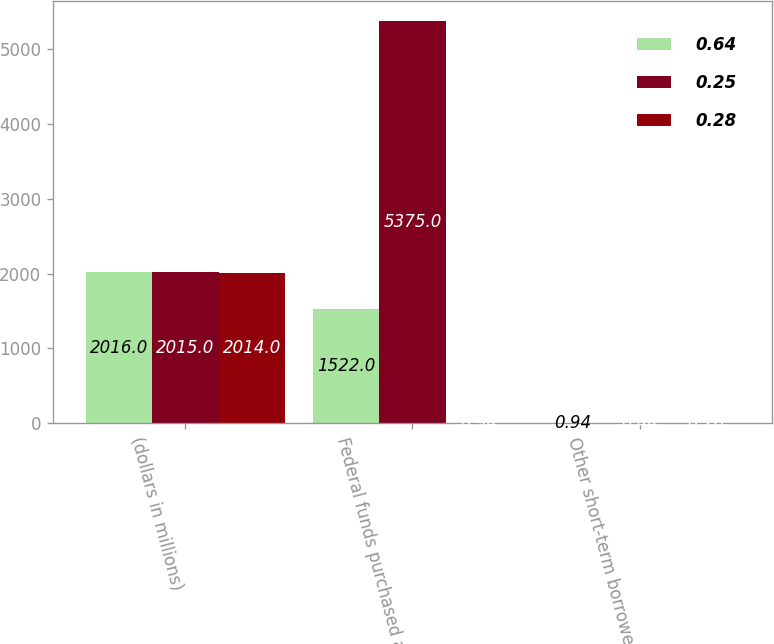Convert chart. <chart><loc_0><loc_0><loc_500><loc_500><stacked_bar_chart><ecel><fcel>(dollars in millions)<fcel>Federal funds purchased and<fcel>Other short-term borrowed<nl><fcel>0.64<fcel>2016<fcel>1522<fcel>0.94<nl><fcel>0.25<fcel>2015<fcel>5375<fcel>0.44<nl><fcel>0.28<fcel>2014<fcel>0.94<fcel>0.26<nl></chart> 